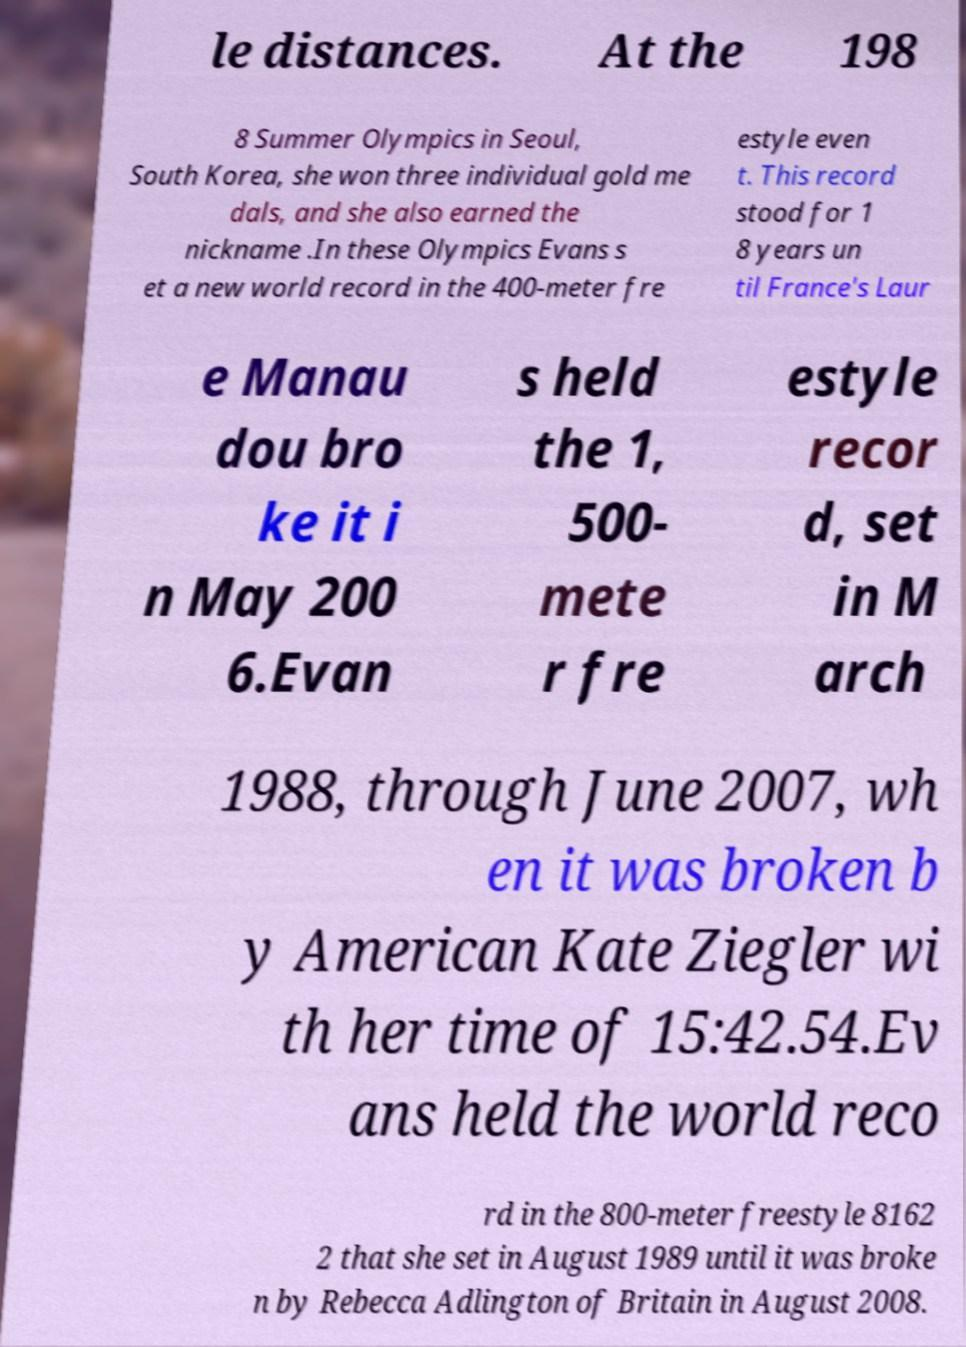For documentation purposes, I need the text within this image transcribed. Could you provide that? le distances. At the 198 8 Summer Olympics in Seoul, South Korea, she won three individual gold me dals, and she also earned the nickname .In these Olympics Evans s et a new world record in the 400-meter fre estyle even t. This record stood for 1 8 years un til France's Laur e Manau dou bro ke it i n May 200 6.Evan s held the 1, 500- mete r fre estyle recor d, set in M arch 1988, through June 2007, wh en it was broken b y American Kate Ziegler wi th her time of 15:42.54.Ev ans held the world reco rd in the 800-meter freestyle 8162 2 that she set in August 1989 until it was broke n by Rebecca Adlington of Britain in August 2008. 